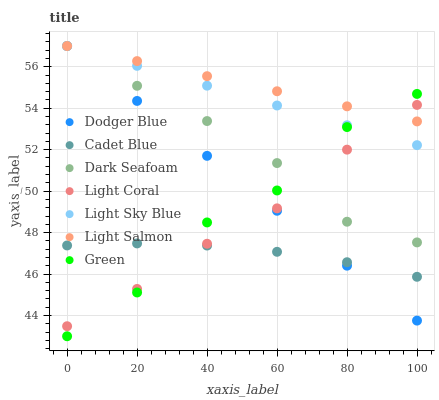Does Cadet Blue have the minimum area under the curve?
Answer yes or no. Yes. Does Light Salmon have the maximum area under the curve?
Answer yes or no. Yes. Does Light Coral have the minimum area under the curve?
Answer yes or no. No. Does Light Coral have the maximum area under the curve?
Answer yes or no. No. Is Dodger Blue the smoothest?
Answer yes or no. Yes. Is Green the roughest?
Answer yes or no. Yes. Is Cadet Blue the smoothest?
Answer yes or no. No. Is Cadet Blue the roughest?
Answer yes or no. No. Does Green have the lowest value?
Answer yes or no. Yes. Does Cadet Blue have the lowest value?
Answer yes or no. No. Does Dodger Blue have the highest value?
Answer yes or no. Yes. Does Light Coral have the highest value?
Answer yes or no. No. Is Cadet Blue less than Dark Seafoam?
Answer yes or no. Yes. Is Light Salmon greater than Cadet Blue?
Answer yes or no. Yes. Does Cadet Blue intersect Green?
Answer yes or no. Yes. Is Cadet Blue less than Green?
Answer yes or no. No. Is Cadet Blue greater than Green?
Answer yes or no. No. Does Cadet Blue intersect Dark Seafoam?
Answer yes or no. No. 